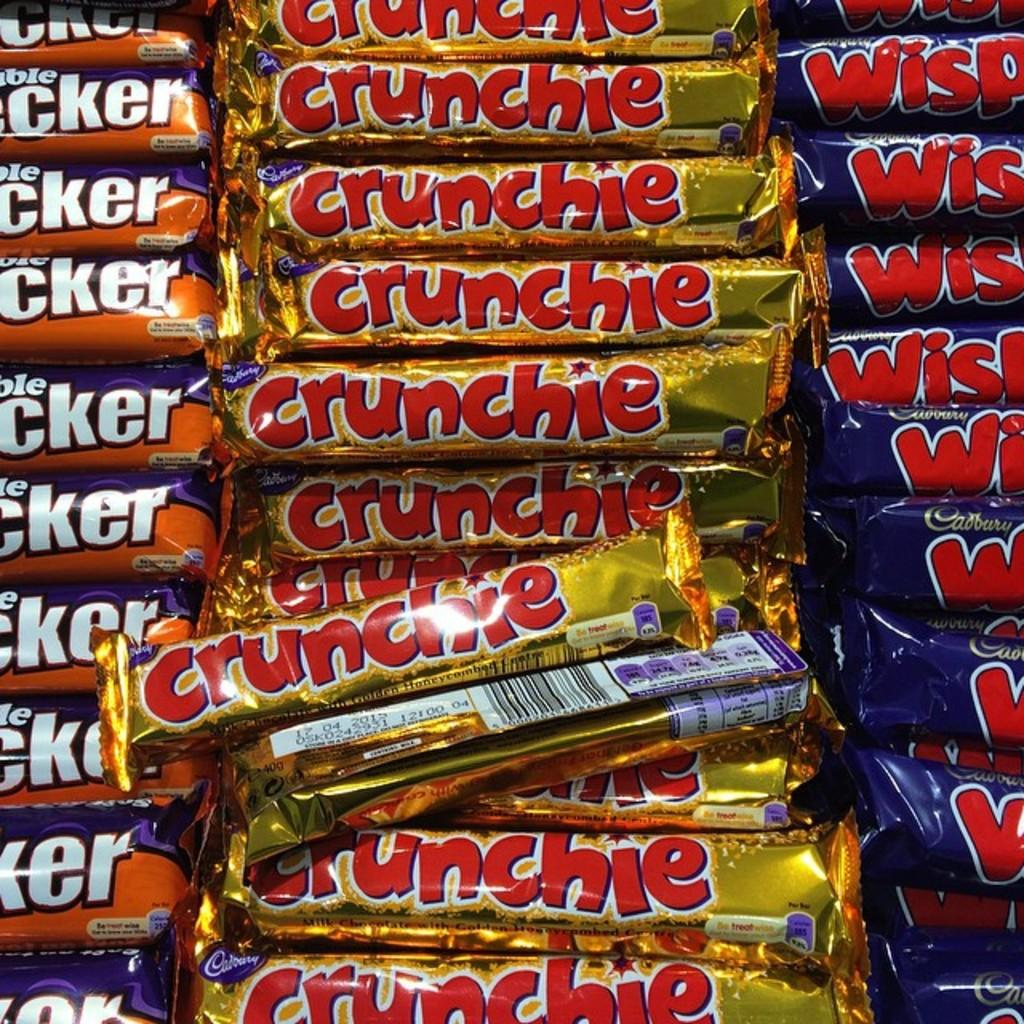What is the main subject of the image? The main subject of the image is a zoomed in picture of chocolates. How many different chocolates can be seen in the image? There are three different chocolates in the image. Can you read the names of the chocolates in the image? Yes, the names of the chocolates are visible on the chocolates. How much tax is deducted from the chocolates in the image? There is no mention of tax or any financial aspect in the image, as it only features chocolates. --- Facts: 1. There is a person sitting on a bench in the image. 2. The person is reading a book. 3. The book has a blue cover. 4. There is a tree behind the bench. 5. The sky is visible in the image. Absurd Topics: dance, ocean, robot Conversation: What is the person in the image doing? The person in the image is sitting on a bench and reading a book. Can you describe the book the person is reading? The book has a blue cover. What can be seen behind the bench in the image? There is a tree behind the bench. What is visible in the background of the image? The sky is visible in the image. Reasoning: Let's think step by step in order to produce the conversation. We start by identifying the main subject of the image, which is the person sitting on the bench. Then, we describe the activity the person is engaged in, which is reading a book. Next, we provide additional details about the book, such as its blue cover. Finally, we mention the presence of a tree and the sky in the background of the image. Absurd Question/Answer: Can you see any robots dancing in the ocean in the image? No, there are no robots or any ocean visible in the image; it features a person sitting on a bench reading a book with a tree and the sky in the background. 